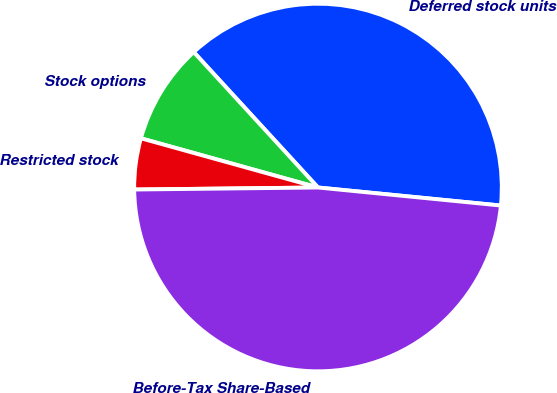Convert chart. <chart><loc_0><loc_0><loc_500><loc_500><pie_chart><fcel>Deferred stock units<fcel>Stock options<fcel>Restricted stock<fcel>Before-Tax Share-Based<nl><fcel>38.38%<fcel>8.87%<fcel>4.49%<fcel>48.26%<nl></chart> 